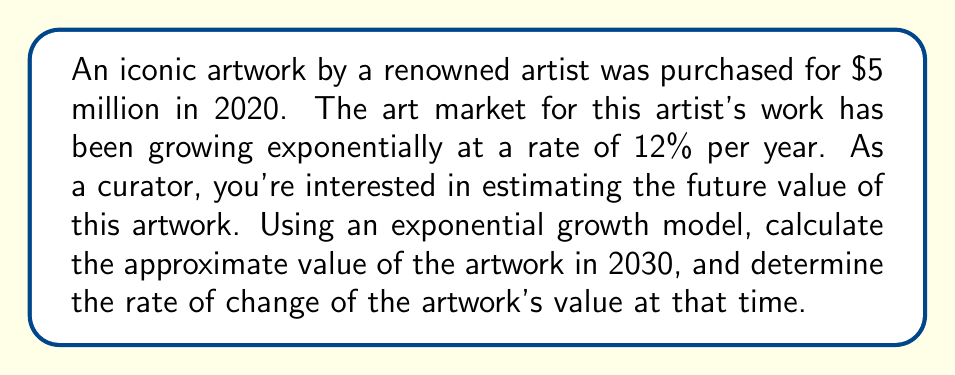Can you answer this question? Let's approach this problem step-by-step:

1) First, we need to set up our exponential growth model. The general form is:

   $V(t) = V_0 e^{rt}$

   Where:
   $V(t)$ is the value at time $t$
   $V_0$ is the initial value
   $r$ is the growth rate
   $t$ is the time in years

2) We know:
   $V_0 = 5,000,000$
   $r = 0.12$ (12% expressed as a decimal)
   $t = 10$ (from 2020 to 2030)

3) Let's calculate the value in 2030:

   $V(10) = 5,000,000 e^{0.12 * 10}$
   $V(10) = 5,000,000 e^{1.2}$
   $V(10) \approx 16,599,161.57$

4) To find the rate of change at this time, we need to take the derivative of our function:

   $\frac{d}{dt}V(t) = V_0 r e^{rt}$

5) Now, let's evaluate this at $t = 10$:

   $\frac{d}{dt}V(10) = 5,000,000 * 0.12 * e^{0.12 * 10}$
   $\frac{d}{dt}V(10) = 600,000 * e^{1.2}$
   $\frac{d}{dt}V(10) \approx 1,991,899.39$

This means the artwork's value is increasing by approximately $1,991,899.39 per year in 2030.
Answer: Value in 2030: $16,599,162; Rate of change: $1,991,899 per year 